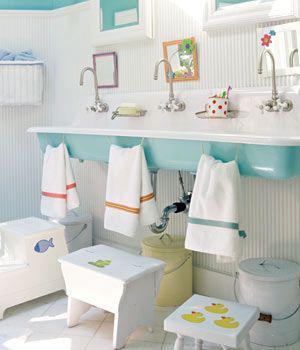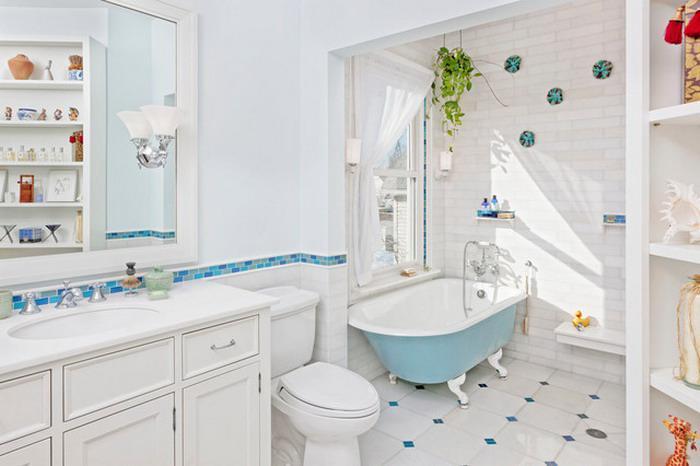The first image is the image on the left, the second image is the image on the right. Examine the images to the left and right. Is the description "One of these images contains two or more footstools, in front of a large sink with multiple faucets." accurate? Answer yes or no. Yes. 